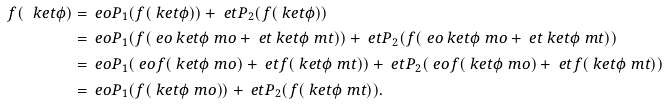<formula> <loc_0><loc_0><loc_500><loc_500>f ( \ k e t { \phi } ) & = \ e o P _ { 1 } ( f ( \ k e t { \phi } ) ) + \ e t P _ { 2 } ( f ( \ k e t { \phi } ) ) \\ & = \ e o P _ { 1 } ( f ( \ e o \ k e t { \phi } _ { \ } m o + \ e t \ k e t { \phi } _ { \ } m t ) ) + \ e t P _ { 2 } ( f ( \ e o \ k e t { \phi } _ { \ } m o + \ e t \ k e t { \phi } _ { \ } m t ) ) \\ & = \ e o P _ { 1 } ( \ e o f ( \ k e t { \phi } _ { \ } m o ) + \ e t f ( \ k e t { \phi } _ { \ } m t ) ) + \ e t P _ { 2 } ( \ e o f ( \ k e t { \phi } _ { \ } m o ) + \ e t f ( \ k e t { \phi } _ { \ } m t ) ) \\ & = \ e o P _ { 1 } ( f ( \ k e t { \phi } _ { \ } m o ) ) + \ e t P _ { 2 } ( f ( \ k e t { \phi } _ { \ } m t ) ) .</formula> 